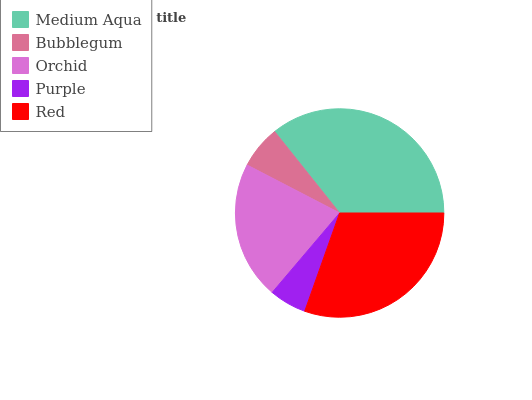Is Purple the minimum?
Answer yes or no. Yes. Is Medium Aqua the maximum?
Answer yes or no. Yes. Is Bubblegum the minimum?
Answer yes or no. No. Is Bubblegum the maximum?
Answer yes or no. No. Is Medium Aqua greater than Bubblegum?
Answer yes or no. Yes. Is Bubblegum less than Medium Aqua?
Answer yes or no. Yes. Is Bubblegum greater than Medium Aqua?
Answer yes or no. No. Is Medium Aqua less than Bubblegum?
Answer yes or no. No. Is Orchid the high median?
Answer yes or no. Yes. Is Orchid the low median?
Answer yes or no. Yes. Is Red the high median?
Answer yes or no. No. Is Purple the low median?
Answer yes or no. No. 